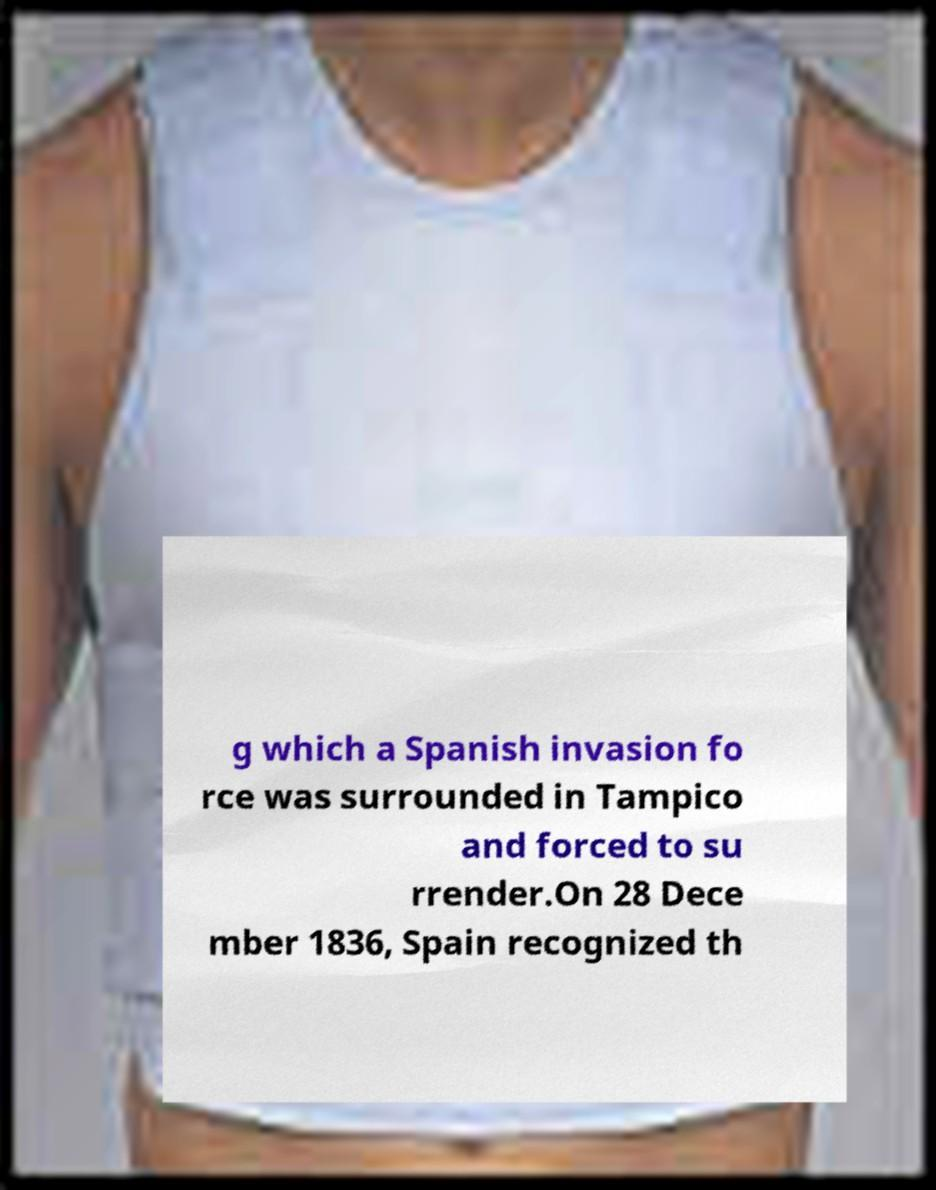I need the written content from this picture converted into text. Can you do that? g which a Spanish invasion fo rce was surrounded in Tampico and forced to su rrender.On 28 Dece mber 1836, Spain recognized th 